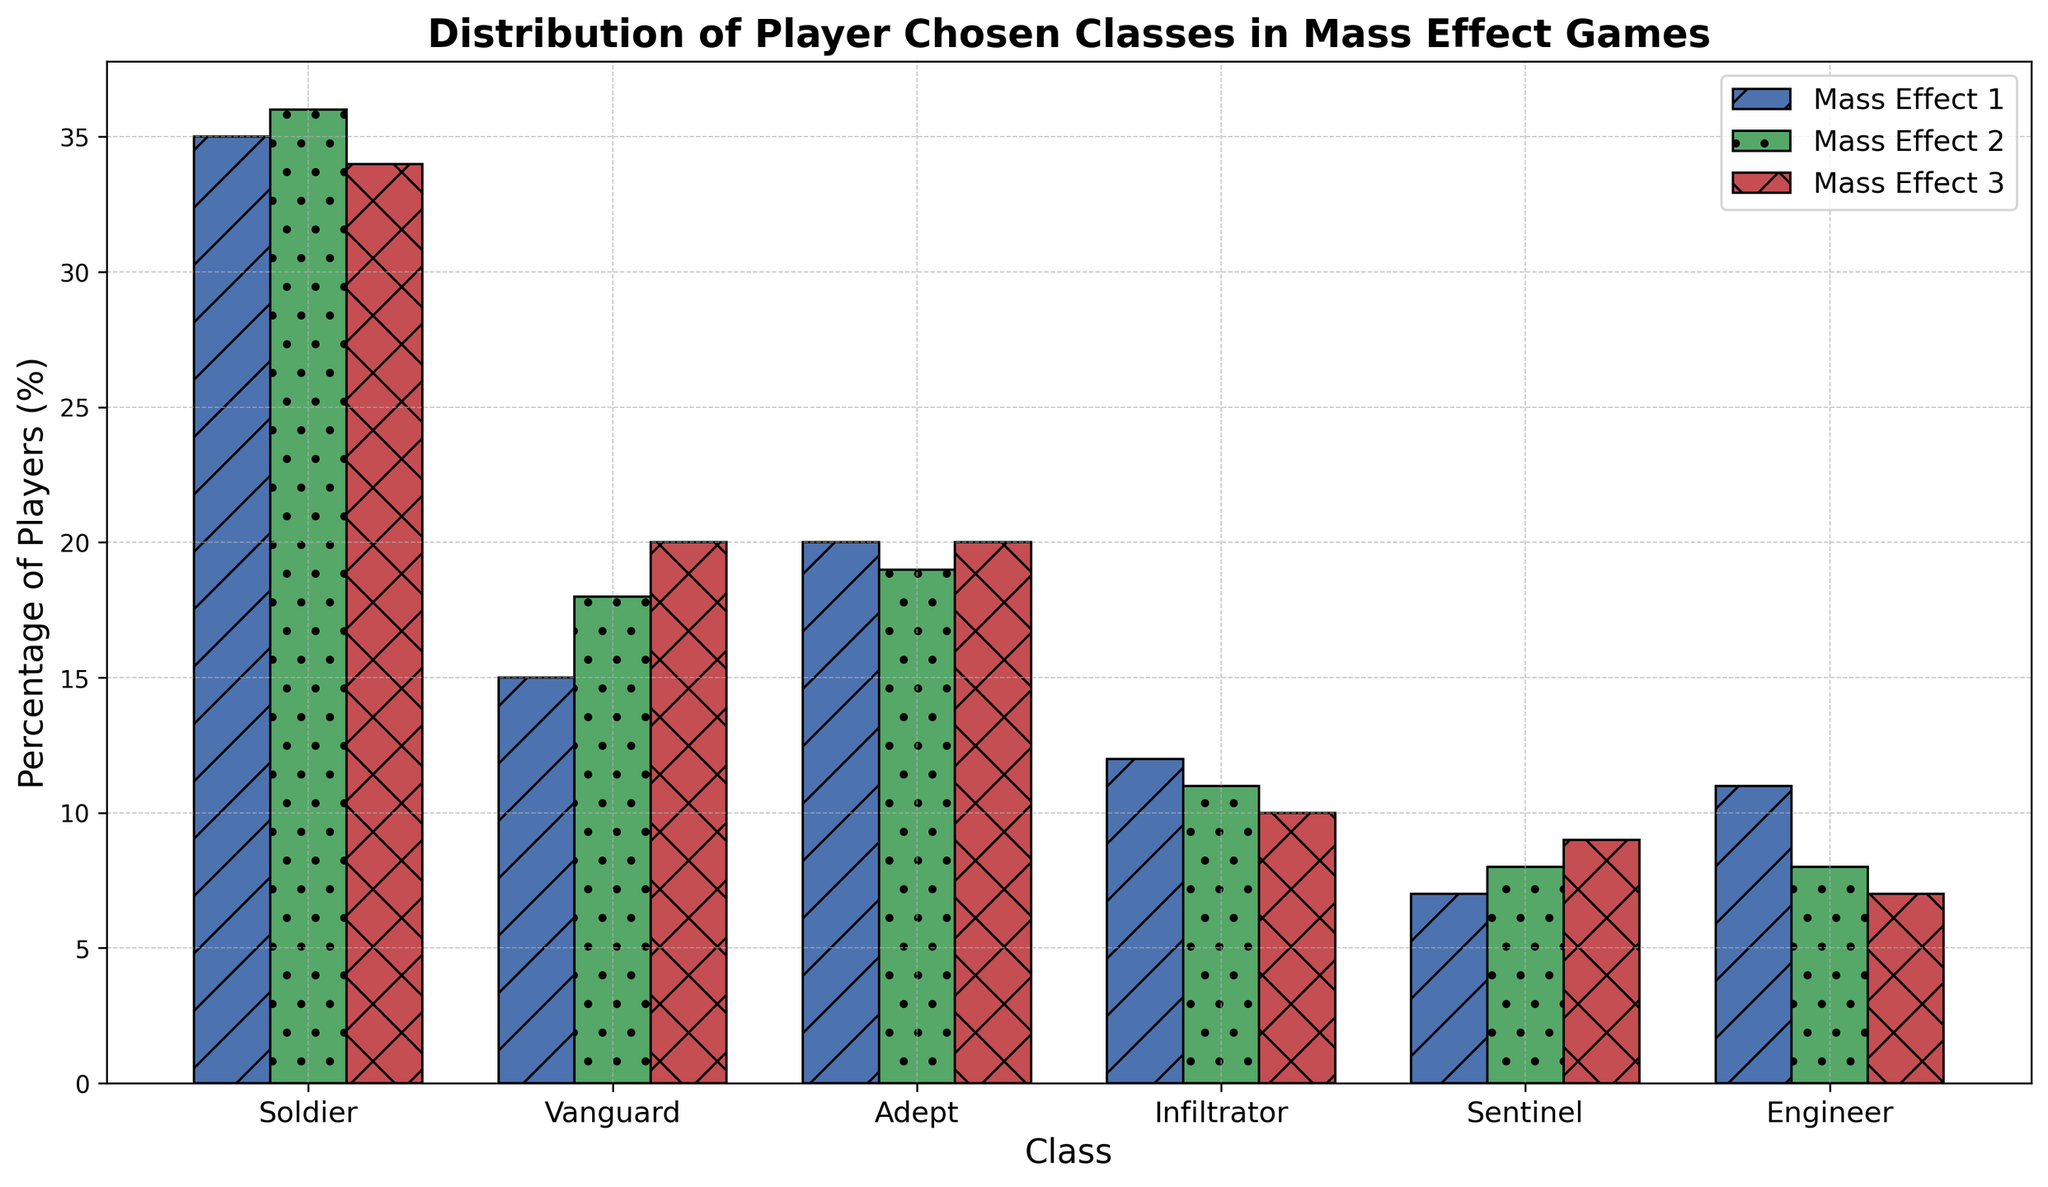What is the most popular class chosen by players in Mass Effect 2? The highest bar in the Mass Effect 2 group is for the Soldier class, indicating it is the most popular.
Answer: Soldier How many more players chose the Soldier class over the Infiltrator class in Mass Effect 1? The bar for Soldier in Mass Effect 1 is at 35, and for Infiltrator, it is at 12. The difference is 35 - 12.
Answer: 23 What class saw the biggest increase in player choice from Mass Effect 1 to Mass Effect 2? By comparing the heights of the bars for each class between the two games, we see that the Vanguard class increased from 15 to 18, which is the largest increase.
Answer: Vanguard Which class saw a decrease in player choice from Mass Effect 2 to Mass Effect 3? Comparing the bars from Mass Effect 2 to Mass Effect 3, both the Infiltrator and Engineer classes saw a decrease, with decreases from 11 to 10 and 8 to 7 respectively.
Answer: Infiltrator, Engineer What is the average percentage of players choosing the Adept class across all three games? The values for the Adept class are 20, 19, and 20. The average is (20 + 19 + 20) / 3.
Answer: 19.67 Which game has the smallest percentage of players choosing the Engineer class? Looking at the height of the bars for the Engineer class, Mass Effect 3 has the smallest percentage at 7.
Answer: Mass Effect 3 In which game does the Sentinel class have the most players? By looking at the bar heights for Sentinel, Mass Effect 3 has the highest bar at 9.
Answer: Mass Effect 3 What is the total percentage of players who chose the Vanguard class over all three games? Adding the heights of the Vanguard bars across all games, 15 + 18 + 20.
Answer: 53 